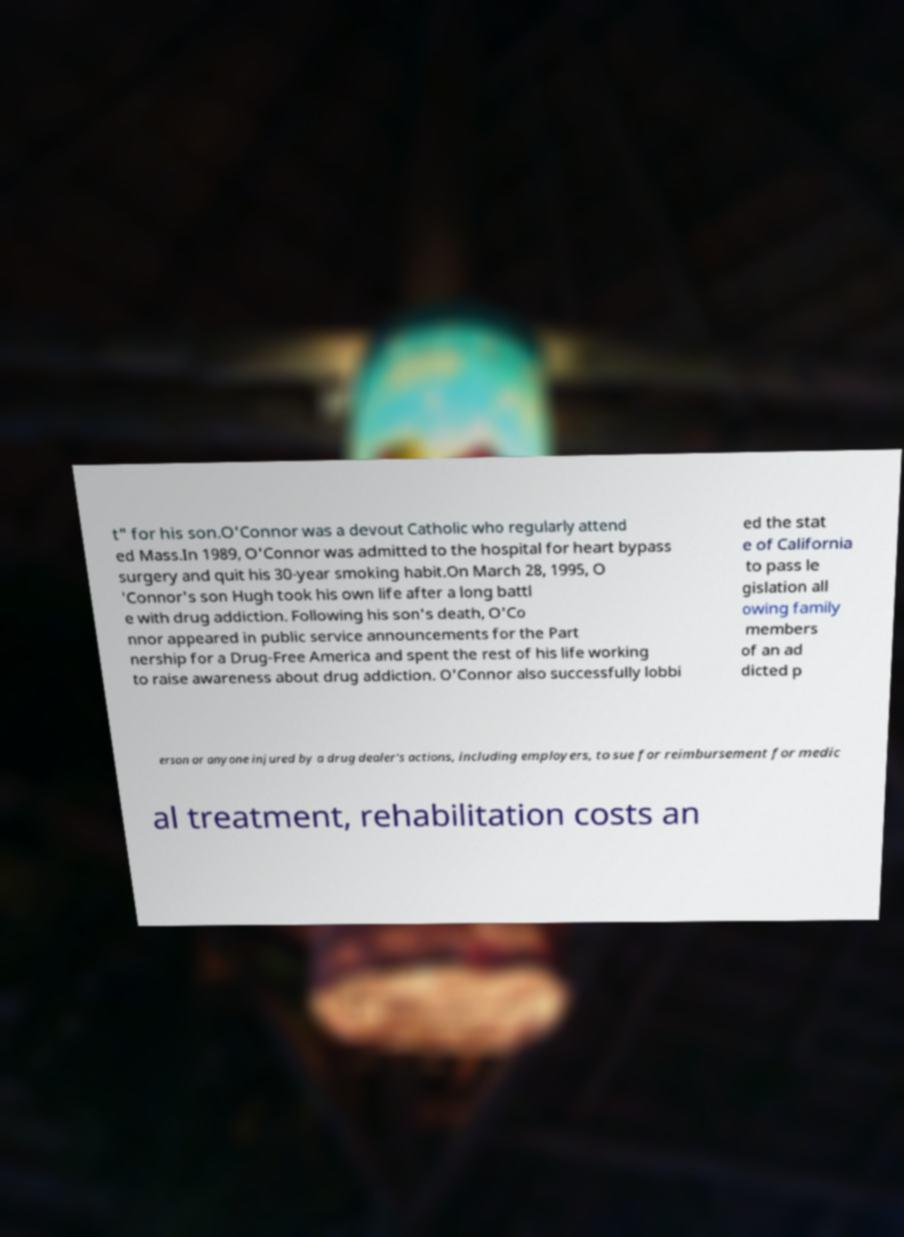For documentation purposes, I need the text within this image transcribed. Could you provide that? t" for his son.O'Connor was a devout Catholic who regularly attend ed Mass.In 1989, O'Connor was admitted to the hospital for heart bypass surgery and quit his 30-year smoking habit.On March 28, 1995, O 'Connor's son Hugh took his own life after a long battl e with drug addiction. Following his son's death, O'Co nnor appeared in public service announcements for the Part nership for a Drug-Free America and spent the rest of his life working to raise awareness about drug addiction. O'Connor also successfully lobbi ed the stat e of California to pass le gislation all owing family members of an ad dicted p erson or anyone injured by a drug dealer's actions, including employers, to sue for reimbursement for medic al treatment, rehabilitation costs an 